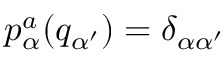<formula> <loc_0><loc_0><loc_500><loc_500>p _ { \alpha } ^ { a } ( q _ { \alpha ^ { \prime } } ) = \delta _ { \alpha \alpha ^ { \prime } }</formula> 